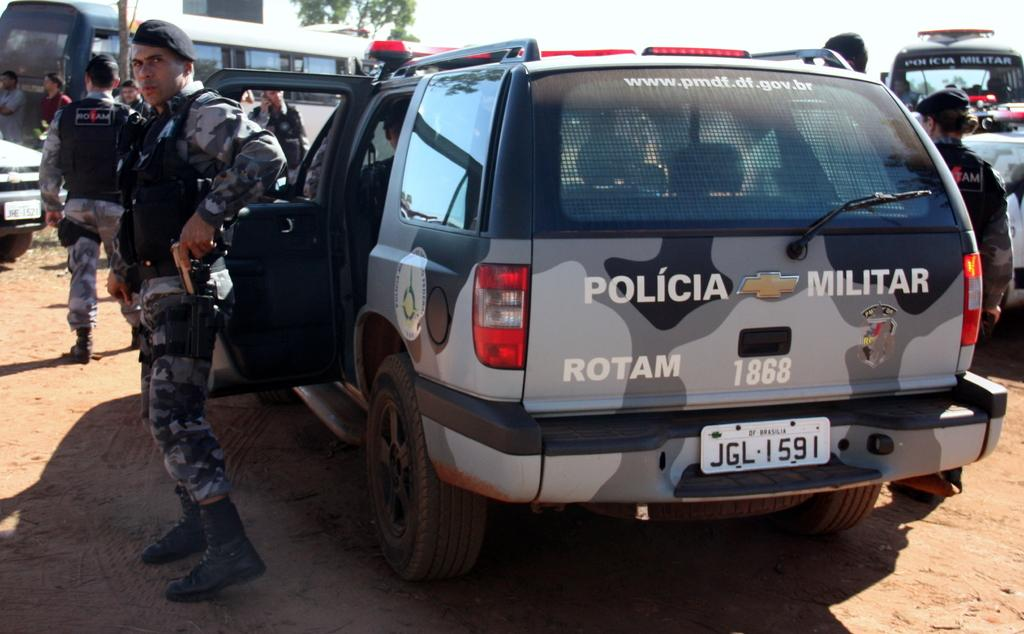What are the people in the image wearing? The people in the image are wearing uniforms and caps. What are the people holding in the image? Some of the people are holding objects. What can be seen on the road in the image? There are vehicles on the road in the image. What is visible in the background of the image? There are trees in the background of the image. What type of liquid can be seen flowing from the giraffe's mouth in the image? There is no giraffe present in the image, and therefore no liquid flowing from its mouth. 